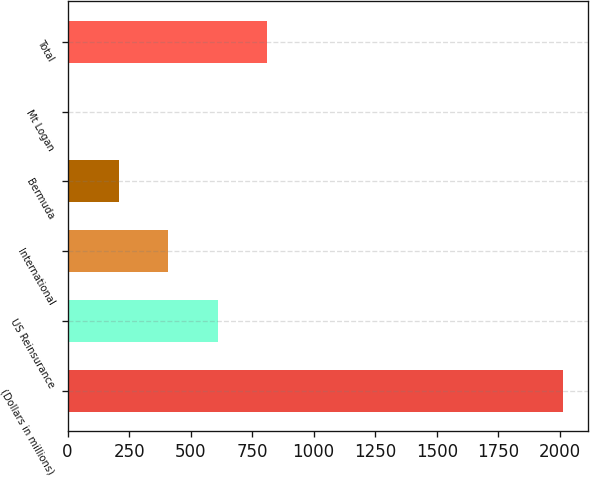Convert chart to OTSL. <chart><loc_0><loc_0><loc_500><loc_500><bar_chart><fcel>(Dollars in millions)<fcel>US Reinsurance<fcel>International<fcel>Bermuda<fcel>Mt Logan<fcel>Total<nl><fcel>2013<fcel>610.34<fcel>409.07<fcel>207.8<fcel>0.3<fcel>811.61<nl></chart> 